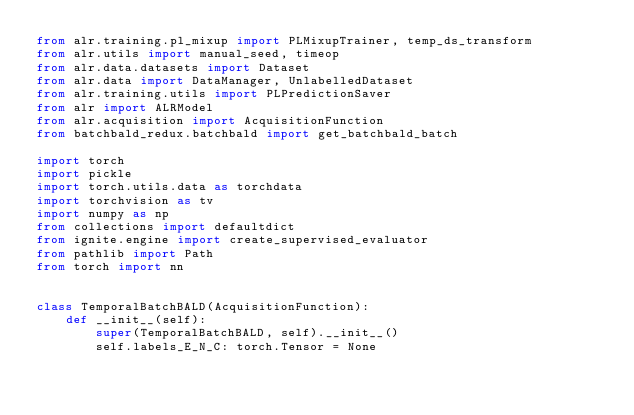Convert code to text. <code><loc_0><loc_0><loc_500><loc_500><_Python_>from alr.training.pl_mixup import PLMixupTrainer, temp_ds_transform
from alr.utils import manual_seed, timeop
from alr.data.datasets import Dataset
from alr.data import DataManager, UnlabelledDataset
from alr.training.utils import PLPredictionSaver
from alr import ALRModel
from alr.acquisition import AcquisitionFunction
from batchbald_redux.batchbald import get_batchbald_batch

import torch
import pickle
import torch.utils.data as torchdata
import torchvision as tv
import numpy as np
from collections import defaultdict
from ignite.engine import create_supervised_evaluator
from pathlib import Path
from torch import nn


class TemporalBatchBALD(AcquisitionFunction):
    def __init__(self):
        super(TemporalBatchBALD, self).__init__()
        self.labels_E_N_C: torch.Tensor = None</code> 